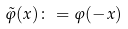<formula> <loc_0><loc_0><loc_500><loc_500>\tilde { \varphi } ( x ) \colon = \varphi ( - x ) \quad</formula> 